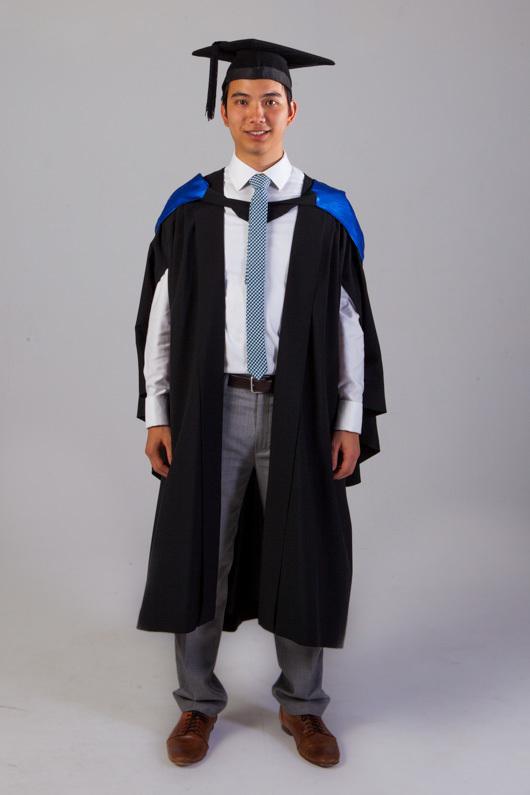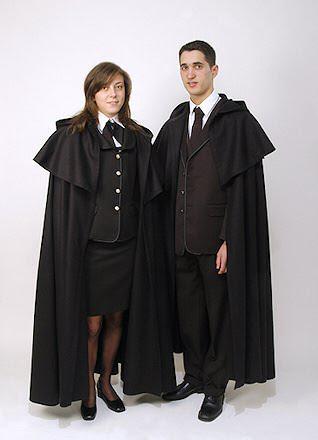The first image is the image on the left, the second image is the image on the right. Evaluate the accuracy of this statement regarding the images: "There are exactly two people shown in both of the images.". Is it true? Answer yes or no. No. 